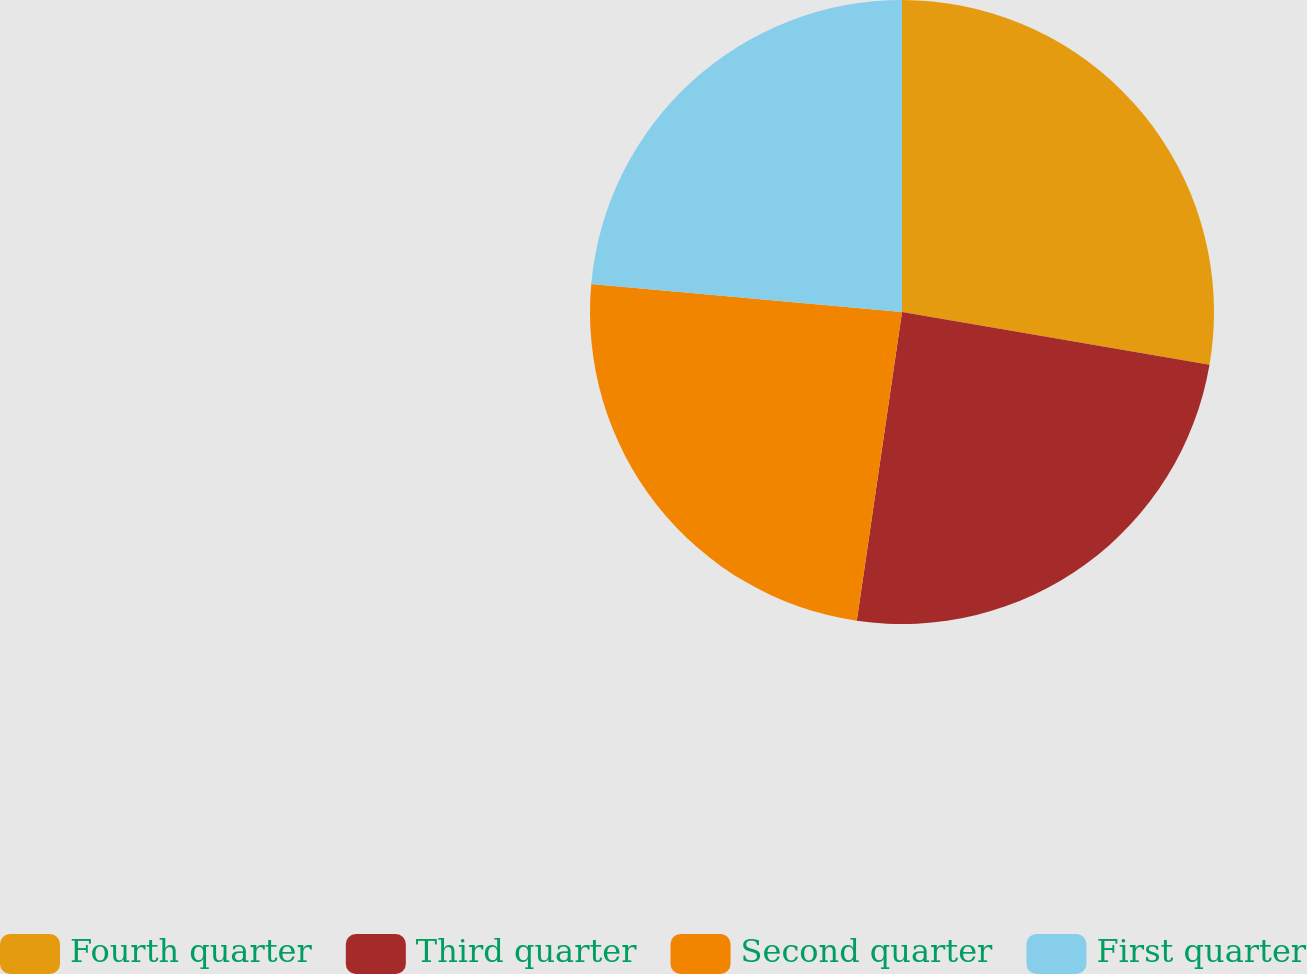<chart> <loc_0><loc_0><loc_500><loc_500><pie_chart><fcel>Fourth quarter<fcel>Third quarter<fcel>Second quarter<fcel>First quarter<nl><fcel>27.7%<fcel>24.61%<fcel>24.11%<fcel>23.57%<nl></chart> 